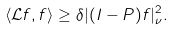<formula> <loc_0><loc_0><loc_500><loc_500>\langle \mathcal { L } f , f \rangle \geq \delta | ( I - P ) f | _ { \nu } ^ { 2 } .</formula> 